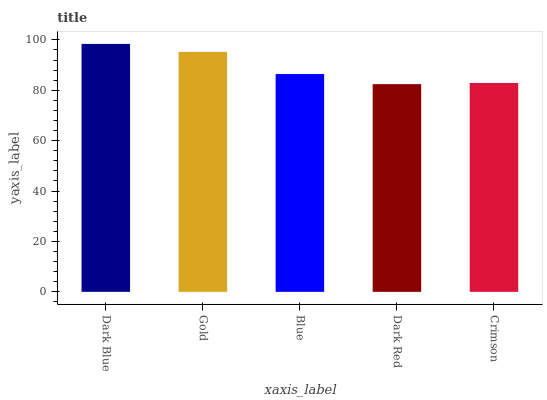Is Dark Red the minimum?
Answer yes or no. Yes. Is Dark Blue the maximum?
Answer yes or no. Yes. Is Gold the minimum?
Answer yes or no. No. Is Gold the maximum?
Answer yes or no. No. Is Dark Blue greater than Gold?
Answer yes or no. Yes. Is Gold less than Dark Blue?
Answer yes or no. Yes. Is Gold greater than Dark Blue?
Answer yes or no. No. Is Dark Blue less than Gold?
Answer yes or no. No. Is Blue the high median?
Answer yes or no. Yes. Is Blue the low median?
Answer yes or no. Yes. Is Dark Red the high median?
Answer yes or no. No. Is Dark Red the low median?
Answer yes or no. No. 